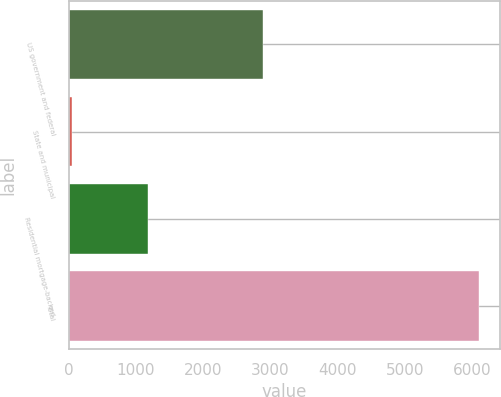<chart> <loc_0><loc_0><loc_500><loc_500><bar_chart><fcel>US government and federal<fcel>State and municipal<fcel>Residential mortgage-backed<fcel>Total<nl><fcel>2889<fcel>50<fcel>1180<fcel>6109<nl></chart> 